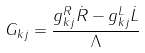<formula> <loc_0><loc_0><loc_500><loc_500>G _ { k j } = \frac { { g _ { k j } ^ { R } \dot { R } - g _ { k j } ^ { L } \dot { L } } } { \Lambda }</formula> 